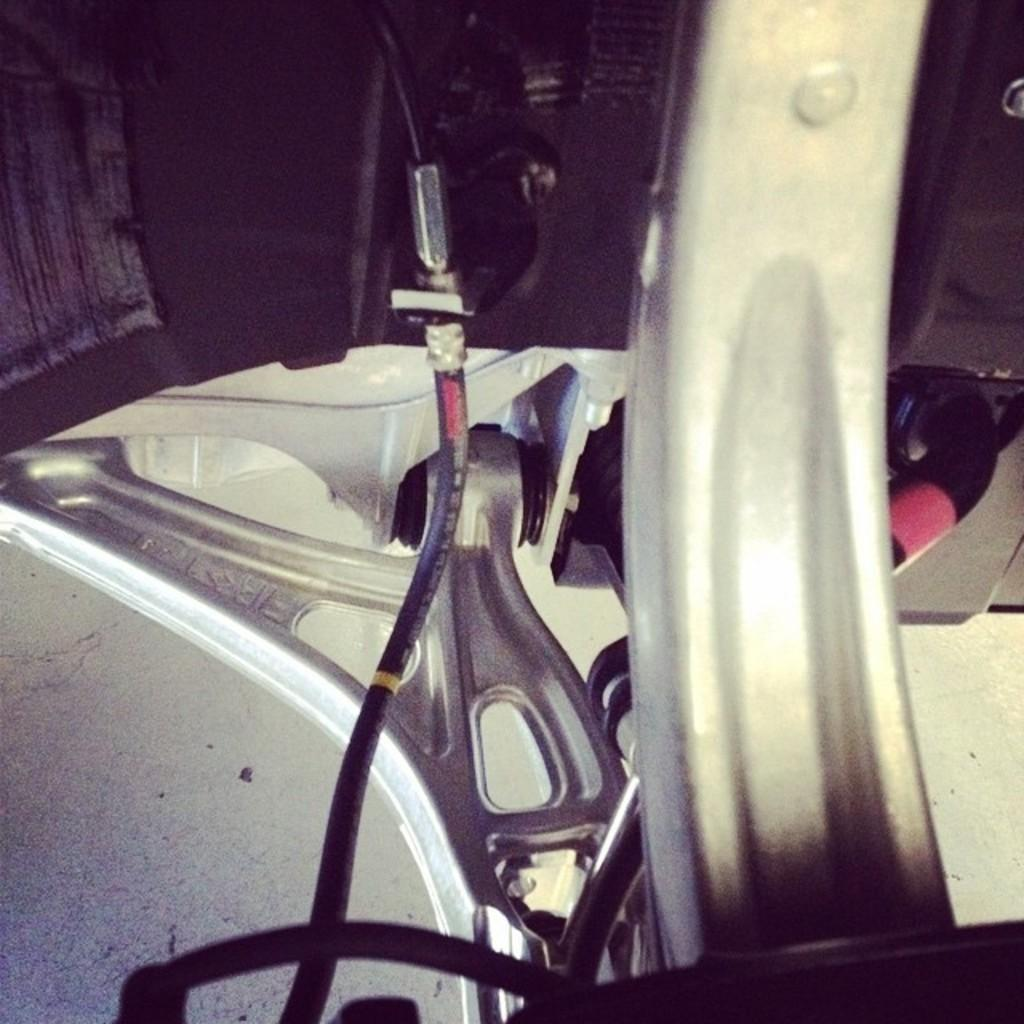What type of machine is visible in the image? There is an electric machine made of metal in the image. What is the primary material used to construct the machine? The machine is made of metal. What is the background of the image? There is a wall in the image. How many tubs are stacked on top of each other in the image? There are no tubs present in the image. What type of crate is visible in the image? There is no crate present in the image. 